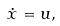Convert formula to latex. <formula><loc_0><loc_0><loc_500><loc_500>\dot { x } = u ,</formula> 